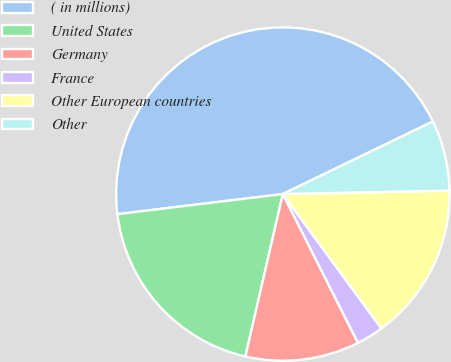<chart> <loc_0><loc_0><loc_500><loc_500><pie_chart><fcel>( in millions)<fcel>United States<fcel>Germany<fcel>France<fcel>Other European countries<fcel>Other<nl><fcel>44.75%<fcel>19.47%<fcel>11.05%<fcel>2.63%<fcel>15.26%<fcel>6.84%<nl></chart> 